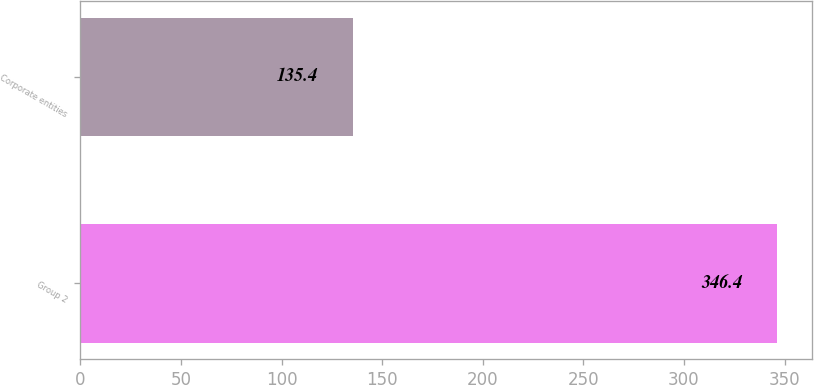Convert chart to OTSL. <chart><loc_0><loc_0><loc_500><loc_500><bar_chart><fcel>Group 2<fcel>Corporate entities<nl><fcel>346.4<fcel>135.4<nl></chart> 